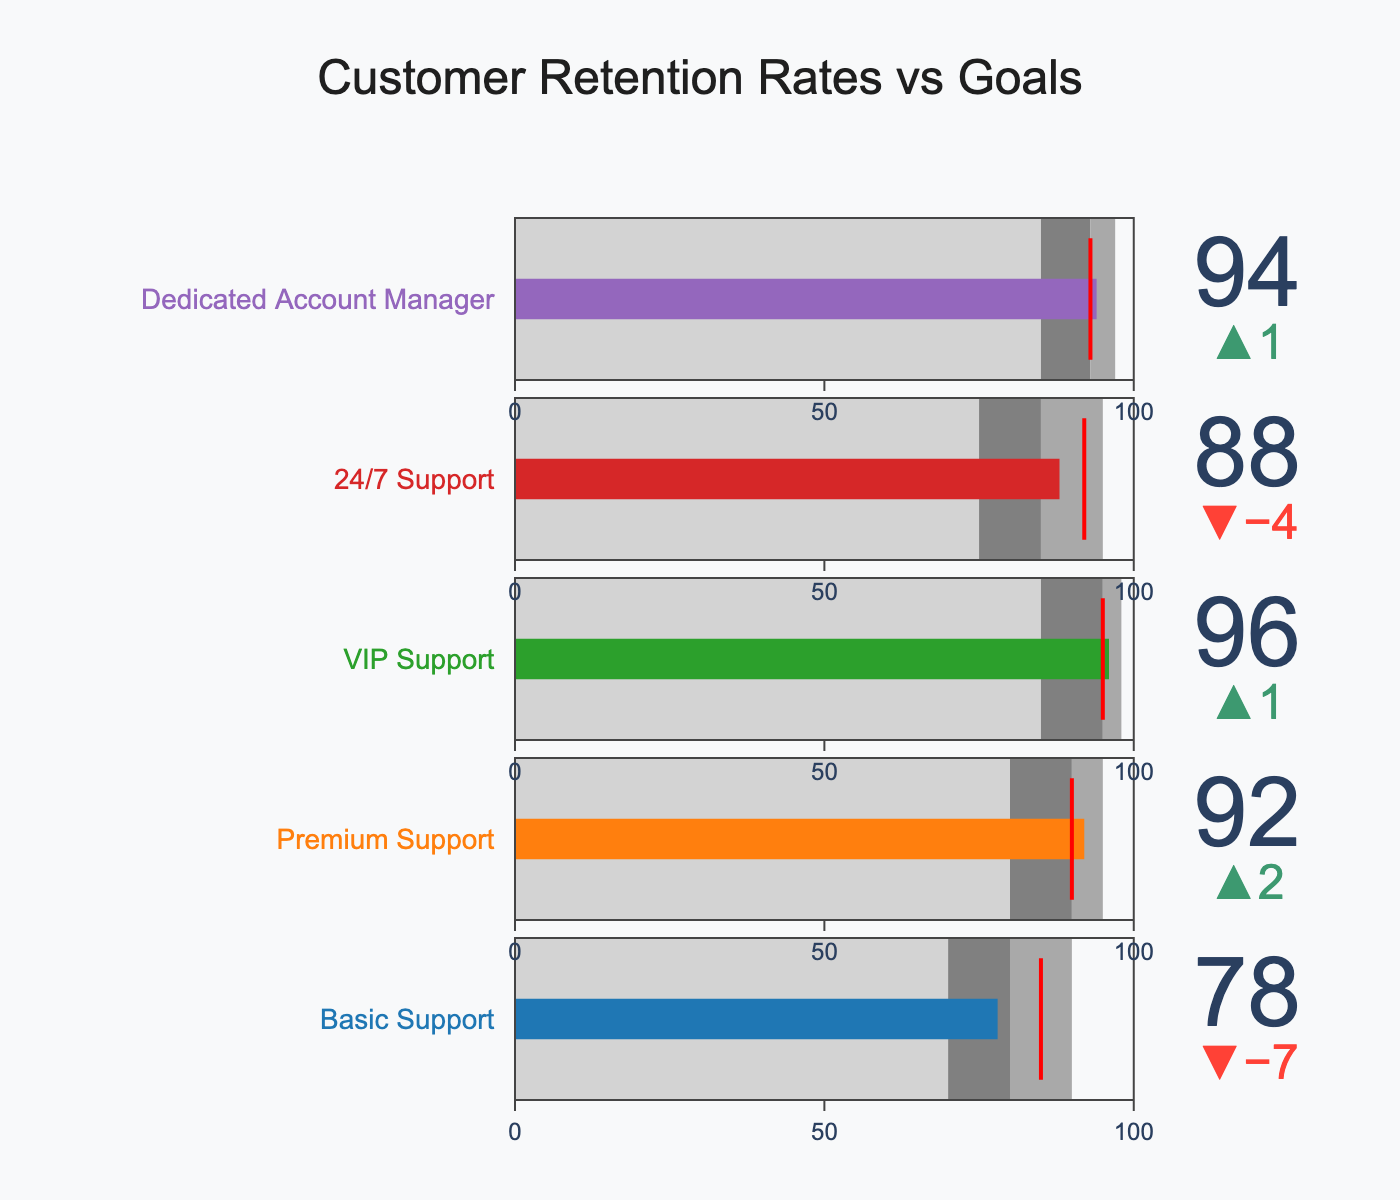What is the title of the chart? The title of the chart is displayed prominently at the top.
Answer: "Customer Retention Rates vs Goals" How many service levels are analyzed in the chart? By counting the number of different service levels along the y-axis, you can see that there are five.
Answer: 5 What is the actual retention rate for Premium Support? Look for the bullet chart labeled "Premium Support" and read the value marked as the actual retention rate.
Answer: 92 Which service level has the highest target retention rate? Compare the target retention rates for all the service levels and identify the highest value.
Answer: VIP Support How much higher is the actual retention rate for Basic Support compared to its poor performance threshold? Subtract the poor performance threshold from the actual retention rate for Basic Support. 78 (actual) - 70 (poor performance) = 8
Answer: 8 Which service level exceeds its target retention rate by the largest margin? Calculate the difference between actual retention rates and target retention rates for each service level, then identify the largest positive difference. VIP Support: 96 - 95 = 1, Premium Support: 92 - 90 = 2, Dedicated Account Manager: 94 - 93 = 1, 24/7 Support: 88 - 92 = -4, Basic Support: 78 - 85 = -7
Answer: Premium Support What color represents the excellent performance range for Premium Support? Look for the bullet chart for Premium Support and identify the color associated with the excellent performance range on the chart.
Answer: Dark gray Is the actual retention rate for Dedicated Account Manager within the satisfactory performance range? Compare the actual retention rate for Dedicated Account Manager with its satisfactory performance range. Satisfactory performance range is 85 to 93, and the actual rate is 94, so it is above satisfactory.
Answer: No Which service levels have actual retention rates that meet or exceed their target retention rates? Compare actual retention rates with target retention rates for each service level and identify the ones that meet or exceed the target. Basic Support (78 < 85), Premium Support (92 ≥ 90), VIP Support (96 ≥ 95), 24/7 Support (88 < 92), Dedicated Account Manager (94 ≥ 93). Therefore, Premium Support, VIP Support, and Dedicated Account Manager meet or exceed their targets.
Answer: Premium Support, VIP Support, Dedicated Account Manager What is the difference between the target retention rate and the excellent performance threshold for 24/7 Support? Subtract the target retention rate from the excellent performance threshold for 24/7 Support. Excellent performance threshold is 95, and target retention rate is 92. So, 95 - 92 = 3.
Answer: 3 